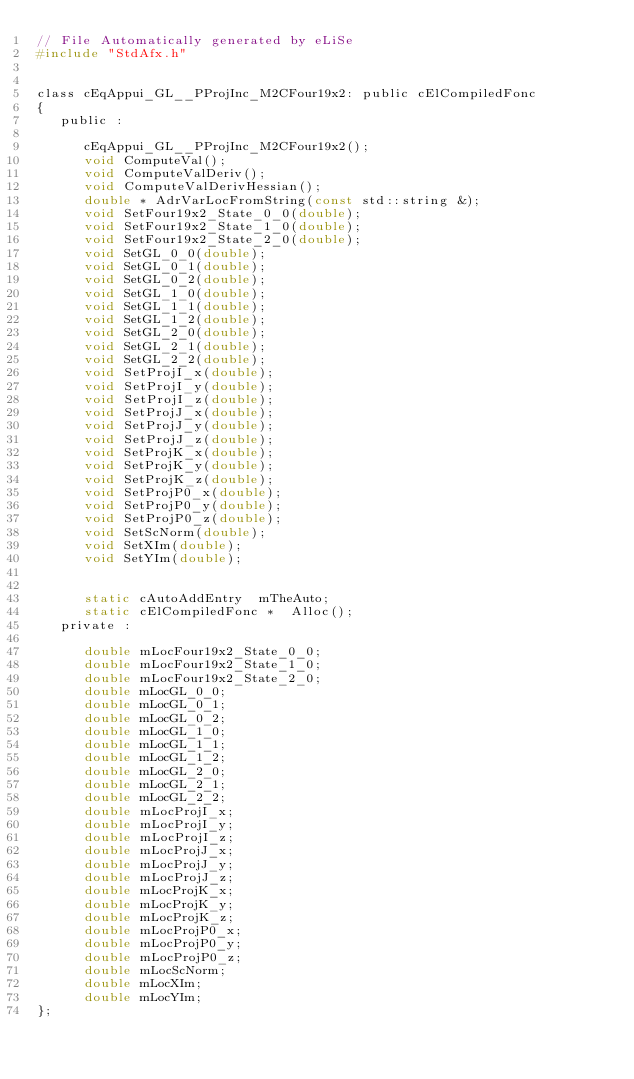<code> <loc_0><loc_0><loc_500><loc_500><_C_>// File Automatically generated by eLiSe
#include "StdAfx.h"


class cEqAppui_GL__PProjInc_M2CFour19x2: public cElCompiledFonc
{
   public :

      cEqAppui_GL__PProjInc_M2CFour19x2();
      void ComputeVal();
      void ComputeValDeriv();
      void ComputeValDerivHessian();
      double * AdrVarLocFromString(const std::string &);
      void SetFour19x2_State_0_0(double);
      void SetFour19x2_State_1_0(double);
      void SetFour19x2_State_2_0(double);
      void SetGL_0_0(double);
      void SetGL_0_1(double);
      void SetGL_0_2(double);
      void SetGL_1_0(double);
      void SetGL_1_1(double);
      void SetGL_1_2(double);
      void SetGL_2_0(double);
      void SetGL_2_1(double);
      void SetGL_2_2(double);
      void SetProjI_x(double);
      void SetProjI_y(double);
      void SetProjI_z(double);
      void SetProjJ_x(double);
      void SetProjJ_y(double);
      void SetProjJ_z(double);
      void SetProjK_x(double);
      void SetProjK_y(double);
      void SetProjK_z(double);
      void SetProjP0_x(double);
      void SetProjP0_y(double);
      void SetProjP0_z(double);
      void SetScNorm(double);
      void SetXIm(double);
      void SetYIm(double);


      static cAutoAddEntry  mTheAuto;
      static cElCompiledFonc *  Alloc();
   private :

      double mLocFour19x2_State_0_0;
      double mLocFour19x2_State_1_0;
      double mLocFour19x2_State_2_0;
      double mLocGL_0_0;
      double mLocGL_0_1;
      double mLocGL_0_2;
      double mLocGL_1_0;
      double mLocGL_1_1;
      double mLocGL_1_2;
      double mLocGL_2_0;
      double mLocGL_2_1;
      double mLocGL_2_2;
      double mLocProjI_x;
      double mLocProjI_y;
      double mLocProjI_z;
      double mLocProjJ_x;
      double mLocProjJ_y;
      double mLocProjJ_z;
      double mLocProjK_x;
      double mLocProjK_y;
      double mLocProjK_z;
      double mLocProjP0_x;
      double mLocProjP0_y;
      double mLocProjP0_z;
      double mLocScNorm;
      double mLocXIm;
      double mLocYIm;
};
</code> 